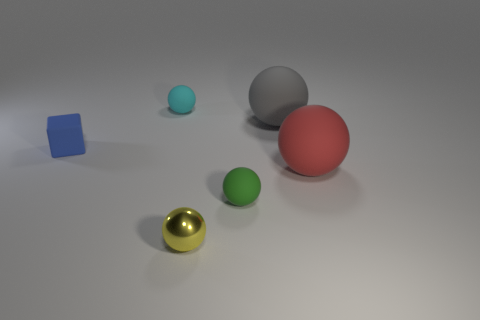Can you describe the different textures and colors present in the objects within the image? Certainly! In the image, there is a variety of textures and colors. Starting with textures, the golden ball has a shiny, reflective surface, suggesting a metallic texture. The red and green balls, as well as the blue cube, have a matte finish giving them a soft, non-reflective look. As for the colors, there's a vibrant red, a bright green, and a shiny gold. The cube is a solid blue, and there's also a smaller cyan-colored ball and a grey ball that exhibits less saturation compared to the others. 